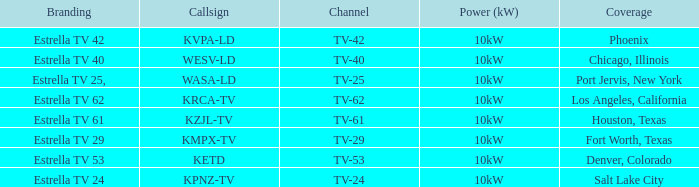List the power output for Phoenix.  10kW. 